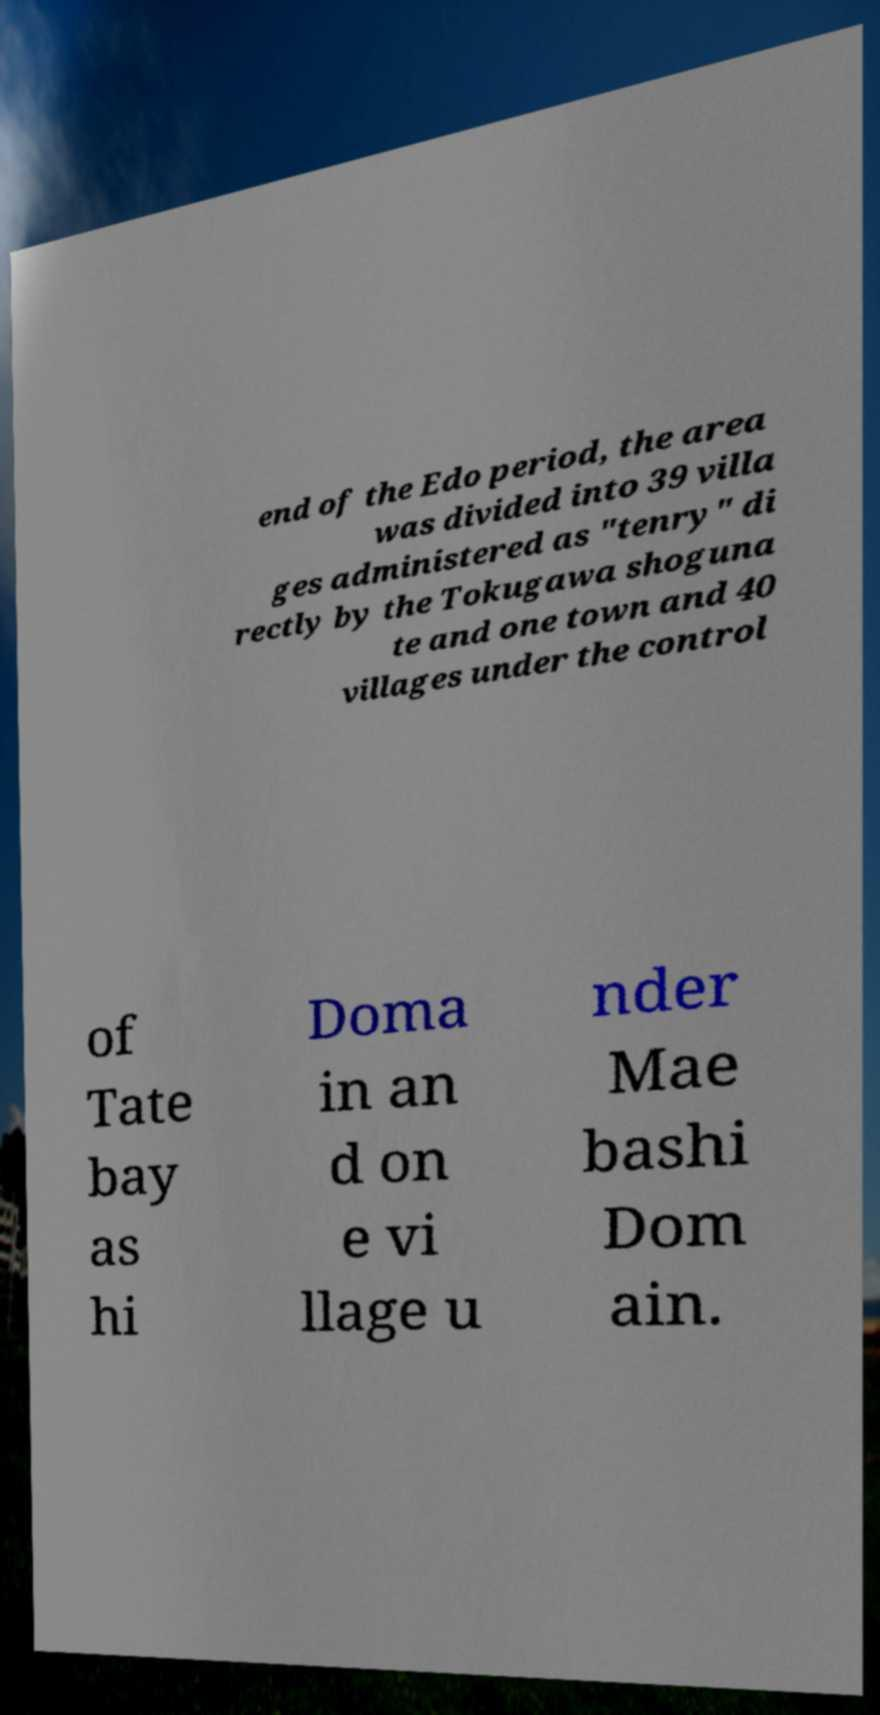Please identify and transcribe the text found in this image. end of the Edo period, the area was divided into 39 villa ges administered as "tenry" di rectly by the Tokugawa shoguna te and one town and 40 villages under the control of Tate bay as hi Doma in an d on e vi llage u nder Mae bashi Dom ain. 